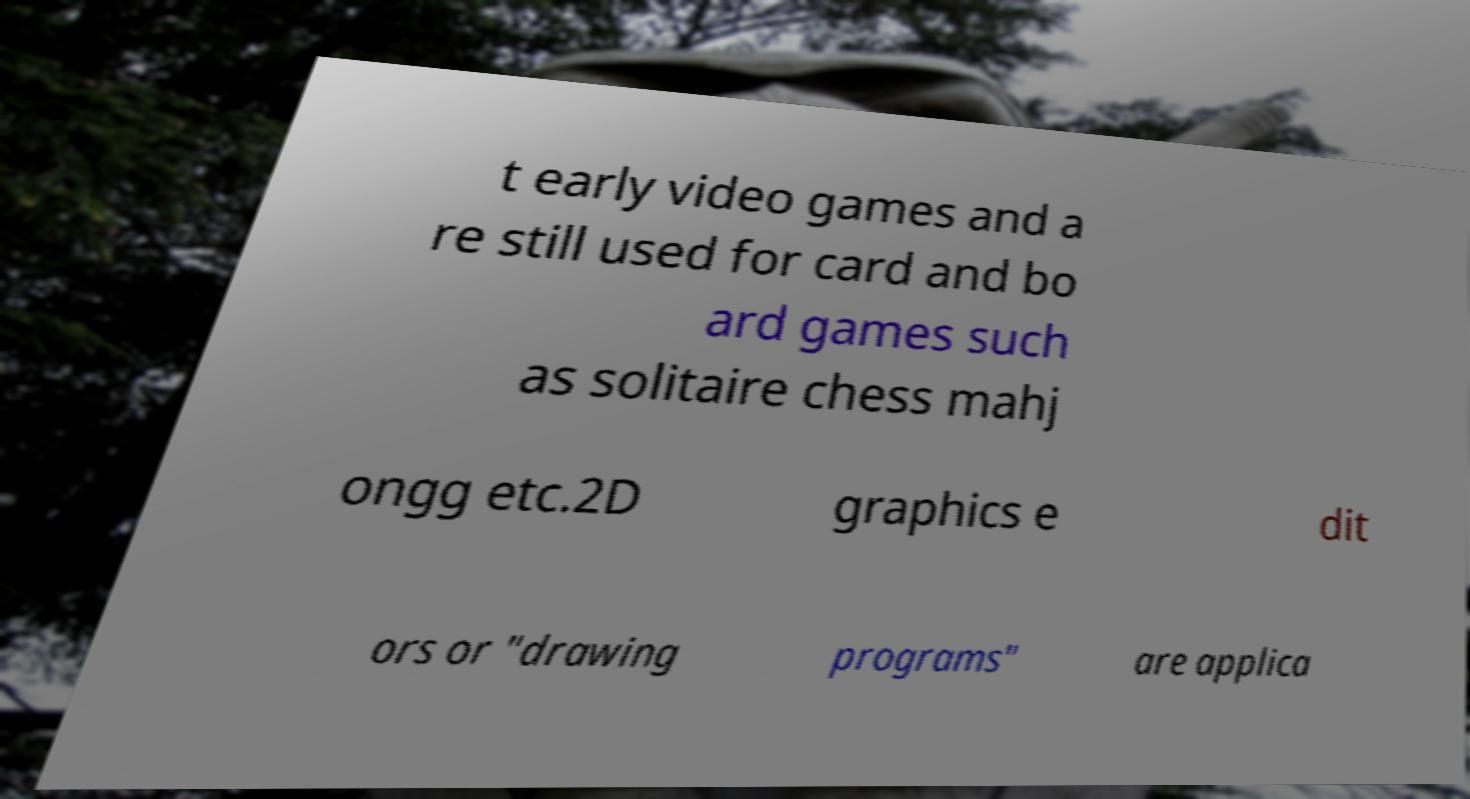Please identify and transcribe the text found in this image. t early video games and a re still used for card and bo ard games such as solitaire chess mahj ongg etc.2D graphics e dit ors or "drawing programs" are applica 